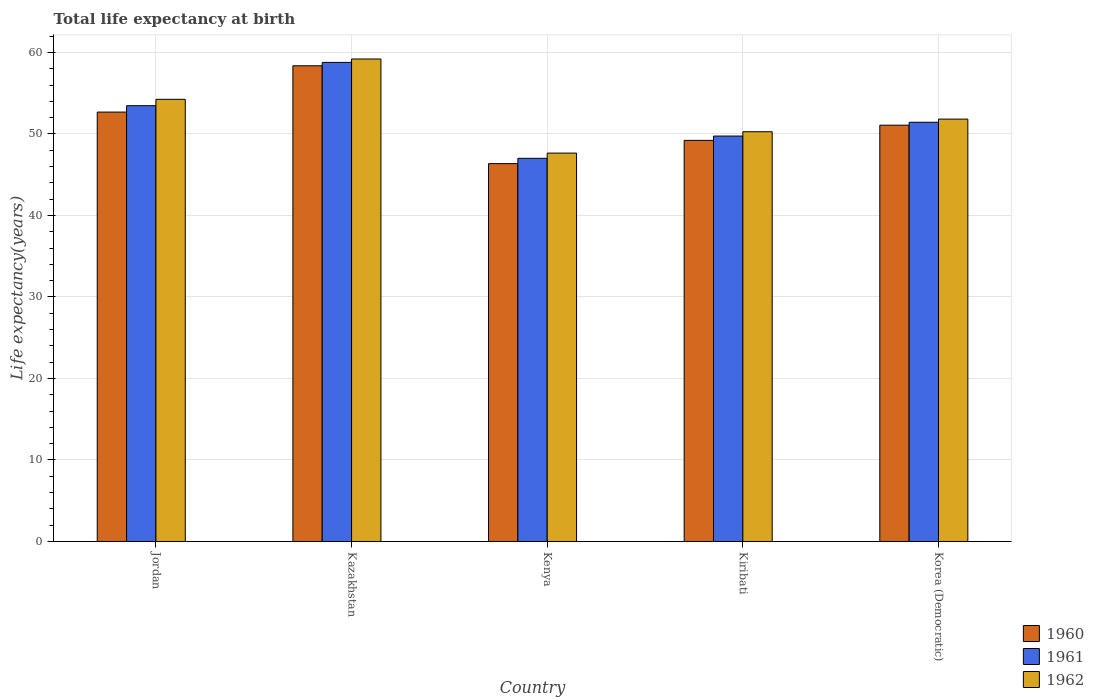How many different coloured bars are there?
Provide a succinct answer. 3. How many groups of bars are there?
Make the answer very short. 5. What is the label of the 2nd group of bars from the left?
Keep it short and to the point. Kazakhstan. In how many cases, is the number of bars for a given country not equal to the number of legend labels?
Your answer should be compact. 0. What is the life expectancy at birth in in 1960 in Jordan?
Your response must be concise. 52.69. Across all countries, what is the maximum life expectancy at birth in in 1962?
Offer a terse response. 59.2. Across all countries, what is the minimum life expectancy at birth in in 1961?
Provide a short and direct response. 47.01. In which country was the life expectancy at birth in in 1960 maximum?
Your answer should be compact. Kazakhstan. In which country was the life expectancy at birth in in 1961 minimum?
Give a very brief answer. Kenya. What is the total life expectancy at birth in in 1962 in the graph?
Your answer should be very brief. 263.2. What is the difference between the life expectancy at birth in in 1960 in Jordan and that in Korea (Democratic)?
Your answer should be compact. 1.61. What is the difference between the life expectancy at birth in in 1961 in Jordan and the life expectancy at birth in in 1962 in Kiribati?
Your response must be concise. 3.2. What is the average life expectancy at birth in in 1961 per country?
Your response must be concise. 52.09. What is the difference between the life expectancy at birth in of/in 1961 and life expectancy at birth in of/in 1962 in Kiribati?
Make the answer very short. -0.53. In how many countries, is the life expectancy at birth in in 1960 greater than 48 years?
Provide a short and direct response. 4. What is the ratio of the life expectancy at birth in in 1961 in Jordan to that in Kazakhstan?
Your answer should be compact. 0.91. Is the difference between the life expectancy at birth in in 1961 in Jordan and Kenya greater than the difference between the life expectancy at birth in in 1962 in Jordan and Kenya?
Offer a terse response. No. What is the difference between the highest and the second highest life expectancy at birth in in 1962?
Give a very brief answer. -7.37. What is the difference between the highest and the lowest life expectancy at birth in in 1960?
Your answer should be very brief. 12.01. Is the sum of the life expectancy at birth in in 1961 in Kazakhstan and Korea (Democratic) greater than the maximum life expectancy at birth in in 1960 across all countries?
Keep it short and to the point. Yes. What does the 1st bar from the left in Korea (Democratic) represents?
Offer a very short reply. 1960. What is the difference between two consecutive major ticks on the Y-axis?
Keep it short and to the point. 10. Where does the legend appear in the graph?
Offer a terse response. Bottom right. What is the title of the graph?
Make the answer very short. Total life expectancy at birth. Does "2008" appear as one of the legend labels in the graph?
Keep it short and to the point. No. What is the label or title of the X-axis?
Provide a succinct answer. Country. What is the label or title of the Y-axis?
Keep it short and to the point. Life expectancy(years). What is the Life expectancy(years) in 1960 in Jordan?
Your answer should be compact. 52.69. What is the Life expectancy(years) in 1961 in Jordan?
Provide a short and direct response. 53.47. What is the Life expectancy(years) in 1962 in Jordan?
Keep it short and to the point. 54.25. What is the Life expectancy(years) of 1960 in Kazakhstan?
Give a very brief answer. 58.37. What is the Life expectancy(years) of 1961 in Kazakhstan?
Make the answer very short. 58.78. What is the Life expectancy(years) in 1962 in Kazakhstan?
Your answer should be very brief. 59.2. What is the Life expectancy(years) in 1960 in Kenya?
Keep it short and to the point. 46.36. What is the Life expectancy(years) of 1961 in Kenya?
Give a very brief answer. 47.01. What is the Life expectancy(years) in 1962 in Kenya?
Offer a very short reply. 47.65. What is the Life expectancy(years) of 1960 in Kiribati?
Your answer should be very brief. 49.22. What is the Life expectancy(years) of 1961 in Kiribati?
Your answer should be compact. 49.74. What is the Life expectancy(years) in 1962 in Kiribati?
Provide a short and direct response. 50.27. What is the Life expectancy(years) of 1960 in Korea (Democratic)?
Offer a very short reply. 51.08. What is the Life expectancy(years) of 1961 in Korea (Democratic)?
Keep it short and to the point. 51.44. What is the Life expectancy(years) of 1962 in Korea (Democratic)?
Keep it short and to the point. 51.83. Across all countries, what is the maximum Life expectancy(years) in 1960?
Provide a short and direct response. 58.37. Across all countries, what is the maximum Life expectancy(years) in 1961?
Provide a short and direct response. 58.78. Across all countries, what is the maximum Life expectancy(years) of 1962?
Ensure brevity in your answer.  59.2. Across all countries, what is the minimum Life expectancy(years) of 1960?
Provide a succinct answer. 46.36. Across all countries, what is the minimum Life expectancy(years) in 1961?
Your answer should be very brief. 47.01. Across all countries, what is the minimum Life expectancy(years) of 1962?
Ensure brevity in your answer.  47.65. What is the total Life expectancy(years) in 1960 in the graph?
Your answer should be compact. 257.71. What is the total Life expectancy(years) of 1961 in the graph?
Give a very brief answer. 260.45. What is the total Life expectancy(years) of 1962 in the graph?
Keep it short and to the point. 263.2. What is the difference between the Life expectancy(years) in 1960 in Jordan and that in Kazakhstan?
Provide a short and direct response. -5.68. What is the difference between the Life expectancy(years) in 1961 in Jordan and that in Kazakhstan?
Keep it short and to the point. -5.31. What is the difference between the Life expectancy(years) in 1962 in Jordan and that in Kazakhstan?
Your answer should be compact. -4.95. What is the difference between the Life expectancy(years) of 1960 in Jordan and that in Kenya?
Offer a terse response. 6.32. What is the difference between the Life expectancy(years) of 1961 in Jordan and that in Kenya?
Your answer should be compact. 6.46. What is the difference between the Life expectancy(years) in 1962 in Jordan and that in Kenya?
Make the answer very short. 6.6. What is the difference between the Life expectancy(years) in 1960 in Jordan and that in Kiribati?
Ensure brevity in your answer.  3.47. What is the difference between the Life expectancy(years) in 1961 in Jordan and that in Kiribati?
Offer a very short reply. 3.73. What is the difference between the Life expectancy(years) of 1962 in Jordan and that in Kiribati?
Provide a succinct answer. 3.98. What is the difference between the Life expectancy(years) of 1960 in Jordan and that in Korea (Democratic)?
Keep it short and to the point. 1.61. What is the difference between the Life expectancy(years) of 1961 in Jordan and that in Korea (Democratic)?
Make the answer very short. 2.03. What is the difference between the Life expectancy(years) of 1962 in Jordan and that in Korea (Democratic)?
Offer a very short reply. 2.43. What is the difference between the Life expectancy(years) in 1960 in Kazakhstan and that in Kenya?
Your answer should be very brief. 12.01. What is the difference between the Life expectancy(years) of 1961 in Kazakhstan and that in Kenya?
Keep it short and to the point. 11.77. What is the difference between the Life expectancy(years) of 1962 in Kazakhstan and that in Kenya?
Ensure brevity in your answer.  11.55. What is the difference between the Life expectancy(years) in 1960 in Kazakhstan and that in Kiribati?
Ensure brevity in your answer.  9.15. What is the difference between the Life expectancy(years) of 1961 in Kazakhstan and that in Kiribati?
Make the answer very short. 9.04. What is the difference between the Life expectancy(years) in 1962 in Kazakhstan and that in Kiribati?
Keep it short and to the point. 8.92. What is the difference between the Life expectancy(years) of 1960 in Kazakhstan and that in Korea (Democratic)?
Your response must be concise. 7.29. What is the difference between the Life expectancy(years) in 1961 in Kazakhstan and that in Korea (Democratic)?
Provide a short and direct response. 7.34. What is the difference between the Life expectancy(years) of 1962 in Kazakhstan and that in Korea (Democratic)?
Your answer should be very brief. 7.37. What is the difference between the Life expectancy(years) of 1960 in Kenya and that in Kiribati?
Ensure brevity in your answer.  -2.85. What is the difference between the Life expectancy(years) in 1961 in Kenya and that in Kiribati?
Provide a succinct answer. -2.73. What is the difference between the Life expectancy(years) in 1962 in Kenya and that in Kiribati?
Your answer should be very brief. -2.62. What is the difference between the Life expectancy(years) in 1960 in Kenya and that in Korea (Democratic)?
Offer a terse response. -4.71. What is the difference between the Life expectancy(years) in 1961 in Kenya and that in Korea (Democratic)?
Your answer should be compact. -4.43. What is the difference between the Life expectancy(years) of 1962 in Kenya and that in Korea (Democratic)?
Your answer should be very brief. -4.17. What is the difference between the Life expectancy(years) in 1960 in Kiribati and that in Korea (Democratic)?
Your answer should be compact. -1.86. What is the difference between the Life expectancy(years) in 1961 in Kiribati and that in Korea (Democratic)?
Give a very brief answer. -1.69. What is the difference between the Life expectancy(years) of 1962 in Kiribati and that in Korea (Democratic)?
Offer a very short reply. -1.55. What is the difference between the Life expectancy(years) of 1960 in Jordan and the Life expectancy(years) of 1961 in Kazakhstan?
Keep it short and to the point. -6.1. What is the difference between the Life expectancy(years) of 1960 in Jordan and the Life expectancy(years) of 1962 in Kazakhstan?
Give a very brief answer. -6.51. What is the difference between the Life expectancy(years) in 1961 in Jordan and the Life expectancy(years) in 1962 in Kazakhstan?
Offer a terse response. -5.73. What is the difference between the Life expectancy(years) of 1960 in Jordan and the Life expectancy(years) of 1961 in Kenya?
Make the answer very short. 5.67. What is the difference between the Life expectancy(years) in 1960 in Jordan and the Life expectancy(years) in 1962 in Kenya?
Provide a short and direct response. 5.03. What is the difference between the Life expectancy(years) of 1961 in Jordan and the Life expectancy(years) of 1962 in Kenya?
Give a very brief answer. 5.82. What is the difference between the Life expectancy(years) in 1960 in Jordan and the Life expectancy(years) in 1961 in Kiribati?
Offer a very short reply. 2.94. What is the difference between the Life expectancy(years) in 1960 in Jordan and the Life expectancy(years) in 1962 in Kiribati?
Give a very brief answer. 2.41. What is the difference between the Life expectancy(years) of 1961 in Jordan and the Life expectancy(years) of 1962 in Kiribati?
Offer a very short reply. 3.2. What is the difference between the Life expectancy(years) of 1960 in Jordan and the Life expectancy(years) of 1961 in Korea (Democratic)?
Provide a succinct answer. 1.25. What is the difference between the Life expectancy(years) in 1960 in Jordan and the Life expectancy(years) in 1962 in Korea (Democratic)?
Your answer should be compact. 0.86. What is the difference between the Life expectancy(years) in 1961 in Jordan and the Life expectancy(years) in 1962 in Korea (Democratic)?
Offer a very short reply. 1.65. What is the difference between the Life expectancy(years) of 1960 in Kazakhstan and the Life expectancy(years) of 1961 in Kenya?
Your answer should be compact. 11.35. What is the difference between the Life expectancy(years) in 1960 in Kazakhstan and the Life expectancy(years) in 1962 in Kenya?
Provide a short and direct response. 10.72. What is the difference between the Life expectancy(years) of 1961 in Kazakhstan and the Life expectancy(years) of 1962 in Kenya?
Your answer should be very brief. 11.13. What is the difference between the Life expectancy(years) in 1960 in Kazakhstan and the Life expectancy(years) in 1961 in Kiribati?
Your answer should be compact. 8.62. What is the difference between the Life expectancy(years) of 1960 in Kazakhstan and the Life expectancy(years) of 1962 in Kiribati?
Offer a very short reply. 8.09. What is the difference between the Life expectancy(years) in 1961 in Kazakhstan and the Life expectancy(years) in 1962 in Kiribati?
Offer a terse response. 8.51. What is the difference between the Life expectancy(years) in 1960 in Kazakhstan and the Life expectancy(years) in 1961 in Korea (Democratic)?
Offer a terse response. 6.93. What is the difference between the Life expectancy(years) of 1960 in Kazakhstan and the Life expectancy(years) of 1962 in Korea (Democratic)?
Provide a short and direct response. 6.54. What is the difference between the Life expectancy(years) of 1961 in Kazakhstan and the Life expectancy(years) of 1962 in Korea (Democratic)?
Make the answer very short. 6.96. What is the difference between the Life expectancy(years) in 1960 in Kenya and the Life expectancy(years) in 1961 in Kiribati?
Ensure brevity in your answer.  -3.38. What is the difference between the Life expectancy(years) in 1960 in Kenya and the Life expectancy(years) in 1962 in Kiribati?
Keep it short and to the point. -3.91. What is the difference between the Life expectancy(years) of 1961 in Kenya and the Life expectancy(years) of 1962 in Kiribati?
Offer a very short reply. -3.26. What is the difference between the Life expectancy(years) of 1960 in Kenya and the Life expectancy(years) of 1961 in Korea (Democratic)?
Ensure brevity in your answer.  -5.08. What is the difference between the Life expectancy(years) in 1960 in Kenya and the Life expectancy(years) in 1962 in Korea (Democratic)?
Offer a very short reply. -5.46. What is the difference between the Life expectancy(years) in 1961 in Kenya and the Life expectancy(years) in 1962 in Korea (Democratic)?
Keep it short and to the point. -4.81. What is the difference between the Life expectancy(years) of 1960 in Kiribati and the Life expectancy(years) of 1961 in Korea (Democratic)?
Offer a very short reply. -2.22. What is the difference between the Life expectancy(years) in 1960 in Kiribati and the Life expectancy(years) in 1962 in Korea (Democratic)?
Give a very brief answer. -2.61. What is the difference between the Life expectancy(years) in 1961 in Kiribati and the Life expectancy(years) in 1962 in Korea (Democratic)?
Offer a very short reply. -2.08. What is the average Life expectancy(years) of 1960 per country?
Keep it short and to the point. 51.54. What is the average Life expectancy(years) of 1961 per country?
Give a very brief answer. 52.09. What is the average Life expectancy(years) in 1962 per country?
Provide a short and direct response. 52.64. What is the difference between the Life expectancy(years) in 1960 and Life expectancy(years) in 1961 in Jordan?
Ensure brevity in your answer.  -0.79. What is the difference between the Life expectancy(years) in 1960 and Life expectancy(years) in 1962 in Jordan?
Offer a terse response. -1.57. What is the difference between the Life expectancy(years) in 1961 and Life expectancy(years) in 1962 in Jordan?
Ensure brevity in your answer.  -0.78. What is the difference between the Life expectancy(years) of 1960 and Life expectancy(years) of 1961 in Kazakhstan?
Provide a short and direct response. -0.41. What is the difference between the Life expectancy(years) of 1960 and Life expectancy(years) of 1962 in Kazakhstan?
Provide a succinct answer. -0.83. What is the difference between the Life expectancy(years) in 1961 and Life expectancy(years) in 1962 in Kazakhstan?
Your answer should be very brief. -0.42. What is the difference between the Life expectancy(years) in 1960 and Life expectancy(years) in 1961 in Kenya?
Offer a very short reply. -0.65. What is the difference between the Life expectancy(years) in 1960 and Life expectancy(years) in 1962 in Kenya?
Give a very brief answer. -1.29. What is the difference between the Life expectancy(years) in 1961 and Life expectancy(years) in 1962 in Kenya?
Provide a short and direct response. -0.64. What is the difference between the Life expectancy(years) of 1960 and Life expectancy(years) of 1961 in Kiribati?
Your response must be concise. -0.53. What is the difference between the Life expectancy(years) in 1960 and Life expectancy(years) in 1962 in Kiribati?
Ensure brevity in your answer.  -1.06. What is the difference between the Life expectancy(years) of 1961 and Life expectancy(years) of 1962 in Kiribati?
Keep it short and to the point. -0.53. What is the difference between the Life expectancy(years) in 1960 and Life expectancy(years) in 1961 in Korea (Democratic)?
Your answer should be very brief. -0.36. What is the difference between the Life expectancy(years) in 1960 and Life expectancy(years) in 1962 in Korea (Democratic)?
Offer a very short reply. -0.75. What is the difference between the Life expectancy(years) of 1961 and Life expectancy(years) of 1962 in Korea (Democratic)?
Ensure brevity in your answer.  -0.39. What is the ratio of the Life expectancy(years) of 1960 in Jordan to that in Kazakhstan?
Give a very brief answer. 0.9. What is the ratio of the Life expectancy(years) in 1961 in Jordan to that in Kazakhstan?
Offer a very short reply. 0.91. What is the ratio of the Life expectancy(years) in 1962 in Jordan to that in Kazakhstan?
Give a very brief answer. 0.92. What is the ratio of the Life expectancy(years) of 1960 in Jordan to that in Kenya?
Give a very brief answer. 1.14. What is the ratio of the Life expectancy(years) of 1961 in Jordan to that in Kenya?
Make the answer very short. 1.14. What is the ratio of the Life expectancy(years) of 1962 in Jordan to that in Kenya?
Your response must be concise. 1.14. What is the ratio of the Life expectancy(years) of 1960 in Jordan to that in Kiribati?
Give a very brief answer. 1.07. What is the ratio of the Life expectancy(years) in 1961 in Jordan to that in Kiribati?
Ensure brevity in your answer.  1.07. What is the ratio of the Life expectancy(years) in 1962 in Jordan to that in Kiribati?
Offer a terse response. 1.08. What is the ratio of the Life expectancy(years) in 1960 in Jordan to that in Korea (Democratic)?
Keep it short and to the point. 1.03. What is the ratio of the Life expectancy(years) of 1961 in Jordan to that in Korea (Democratic)?
Provide a succinct answer. 1.04. What is the ratio of the Life expectancy(years) in 1962 in Jordan to that in Korea (Democratic)?
Ensure brevity in your answer.  1.05. What is the ratio of the Life expectancy(years) of 1960 in Kazakhstan to that in Kenya?
Make the answer very short. 1.26. What is the ratio of the Life expectancy(years) in 1961 in Kazakhstan to that in Kenya?
Your answer should be very brief. 1.25. What is the ratio of the Life expectancy(years) of 1962 in Kazakhstan to that in Kenya?
Keep it short and to the point. 1.24. What is the ratio of the Life expectancy(years) of 1960 in Kazakhstan to that in Kiribati?
Offer a very short reply. 1.19. What is the ratio of the Life expectancy(years) of 1961 in Kazakhstan to that in Kiribati?
Provide a succinct answer. 1.18. What is the ratio of the Life expectancy(years) in 1962 in Kazakhstan to that in Kiribati?
Your response must be concise. 1.18. What is the ratio of the Life expectancy(years) of 1960 in Kazakhstan to that in Korea (Democratic)?
Offer a terse response. 1.14. What is the ratio of the Life expectancy(years) in 1961 in Kazakhstan to that in Korea (Democratic)?
Give a very brief answer. 1.14. What is the ratio of the Life expectancy(years) in 1962 in Kazakhstan to that in Korea (Democratic)?
Offer a very short reply. 1.14. What is the ratio of the Life expectancy(years) in 1960 in Kenya to that in Kiribati?
Your response must be concise. 0.94. What is the ratio of the Life expectancy(years) of 1961 in Kenya to that in Kiribati?
Make the answer very short. 0.95. What is the ratio of the Life expectancy(years) in 1962 in Kenya to that in Kiribati?
Offer a terse response. 0.95. What is the ratio of the Life expectancy(years) in 1960 in Kenya to that in Korea (Democratic)?
Your answer should be very brief. 0.91. What is the ratio of the Life expectancy(years) in 1961 in Kenya to that in Korea (Democratic)?
Your answer should be compact. 0.91. What is the ratio of the Life expectancy(years) of 1962 in Kenya to that in Korea (Democratic)?
Your answer should be compact. 0.92. What is the ratio of the Life expectancy(years) in 1960 in Kiribati to that in Korea (Democratic)?
Keep it short and to the point. 0.96. What is the ratio of the Life expectancy(years) of 1961 in Kiribati to that in Korea (Democratic)?
Keep it short and to the point. 0.97. What is the ratio of the Life expectancy(years) in 1962 in Kiribati to that in Korea (Democratic)?
Give a very brief answer. 0.97. What is the difference between the highest and the second highest Life expectancy(years) in 1960?
Offer a very short reply. 5.68. What is the difference between the highest and the second highest Life expectancy(years) in 1961?
Ensure brevity in your answer.  5.31. What is the difference between the highest and the second highest Life expectancy(years) in 1962?
Your answer should be very brief. 4.95. What is the difference between the highest and the lowest Life expectancy(years) of 1960?
Your response must be concise. 12.01. What is the difference between the highest and the lowest Life expectancy(years) of 1961?
Keep it short and to the point. 11.77. What is the difference between the highest and the lowest Life expectancy(years) of 1962?
Your answer should be very brief. 11.55. 